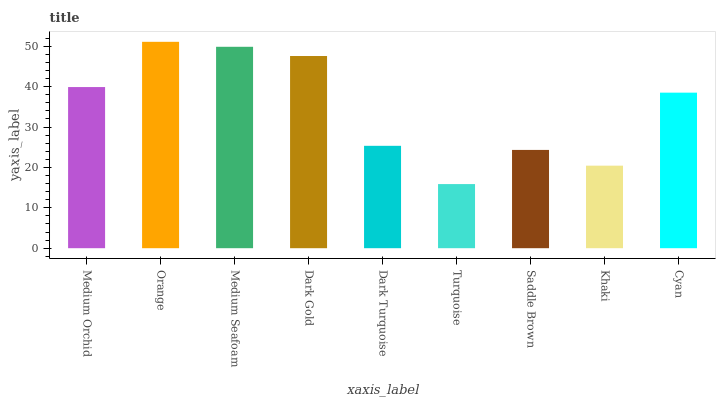Is Turquoise the minimum?
Answer yes or no. Yes. Is Orange the maximum?
Answer yes or no. Yes. Is Medium Seafoam the minimum?
Answer yes or no. No. Is Medium Seafoam the maximum?
Answer yes or no. No. Is Orange greater than Medium Seafoam?
Answer yes or no. Yes. Is Medium Seafoam less than Orange?
Answer yes or no. Yes. Is Medium Seafoam greater than Orange?
Answer yes or no. No. Is Orange less than Medium Seafoam?
Answer yes or no. No. Is Cyan the high median?
Answer yes or no. Yes. Is Cyan the low median?
Answer yes or no. Yes. Is Orange the high median?
Answer yes or no. No. Is Medium Seafoam the low median?
Answer yes or no. No. 